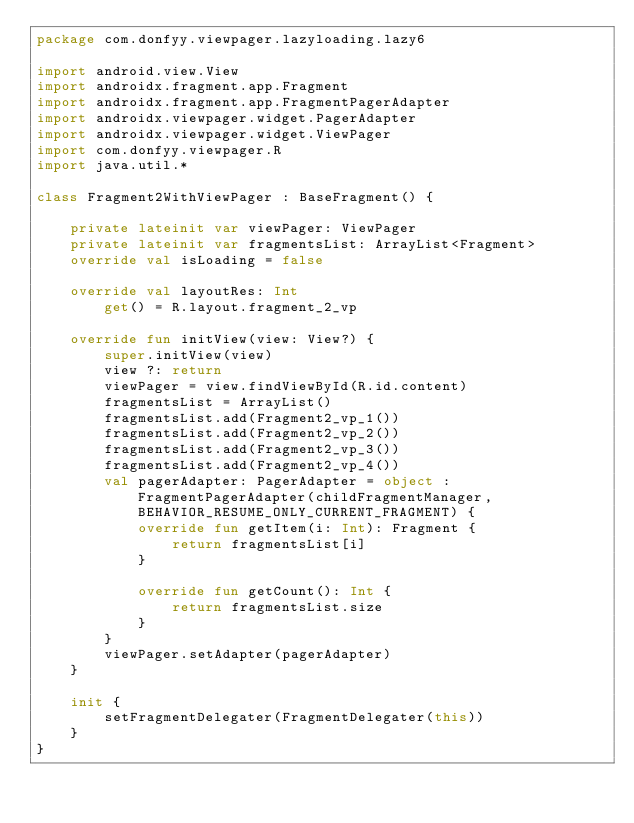<code> <loc_0><loc_0><loc_500><loc_500><_Kotlin_>package com.donfyy.viewpager.lazyloading.lazy6

import android.view.View
import androidx.fragment.app.Fragment
import androidx.fragment.app.FragmentPagerAdapter
import androidx.viewpager.widget.PagerAdapter
import androidx.viewpager.widget.ViewPager
import com.donfyy.viewpager.R
import java.util.*

class Fragment2WithViewPager : BaseFragment() {

    private lateinit var viewPager: ViewPager
    private lateinit var fragmentsList: ArrayList<Fragment>
    override val isLoading = false

    override val layoutRes: Int
        get() = R.layout.fragment_2_vp

    override fun initView(view: View?) {
        super.initView(view)
        view ?: return
        viewPager = view.findViewById(R.id.content)
        fragmentsList = ArrayList()
        fragmentsList.add(Fragment2_vp_1())
        fragmentsList.add(Fragment2_vp_2())
        fragmentsList.add(Fragment2_vp_3())
        fragmentsList.add(Fragment2_vp_4())
        val pagerAdapter: PagerAdapter = object : FragmentPagerAdapter(childFragmentManager, BEHAVIOR_RESUME_ONLY_CURRENT_FRAGMENT) {
            override fun getItem(i: Int): Fragment {
                return fragmentsList[i]
            }

            override fun getCount(): Int {
                return fragmentsList.size
            }
        }
        viewPager.setAdapter(pagerAdapter)
    }

    init {
        setFragmentDelegater(FragmentDelegater(this))
    }
}</code> 